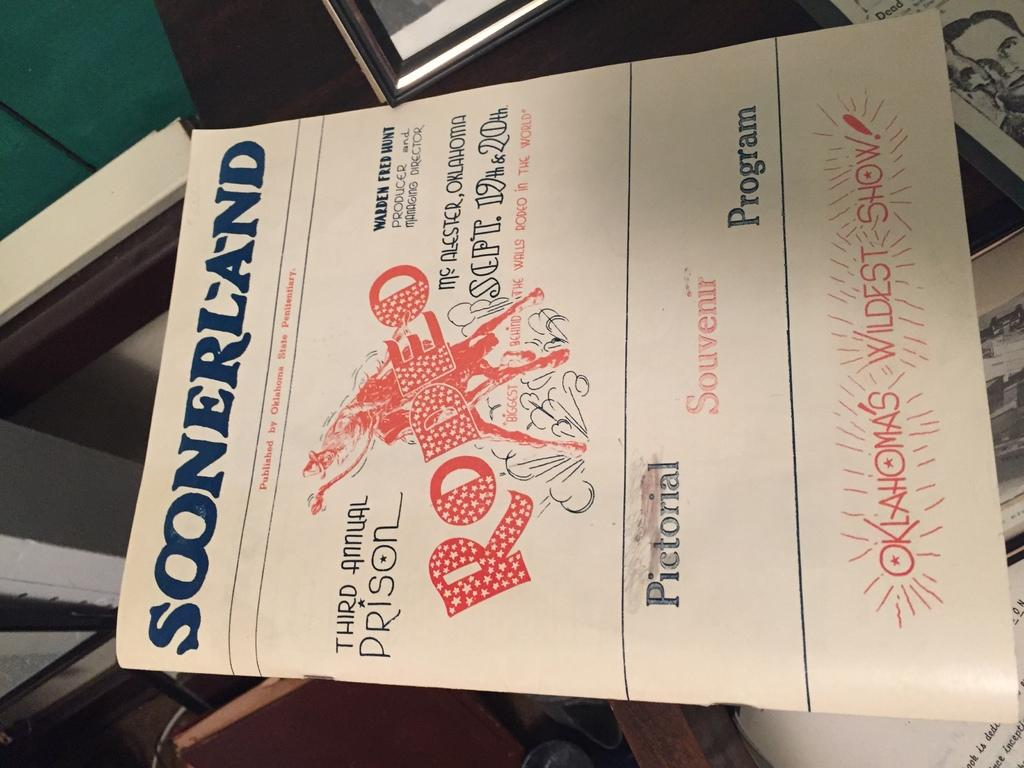Provide a one-sentence caption for the provided image. A flyer for a rodeo called Soonerland is advertised. 